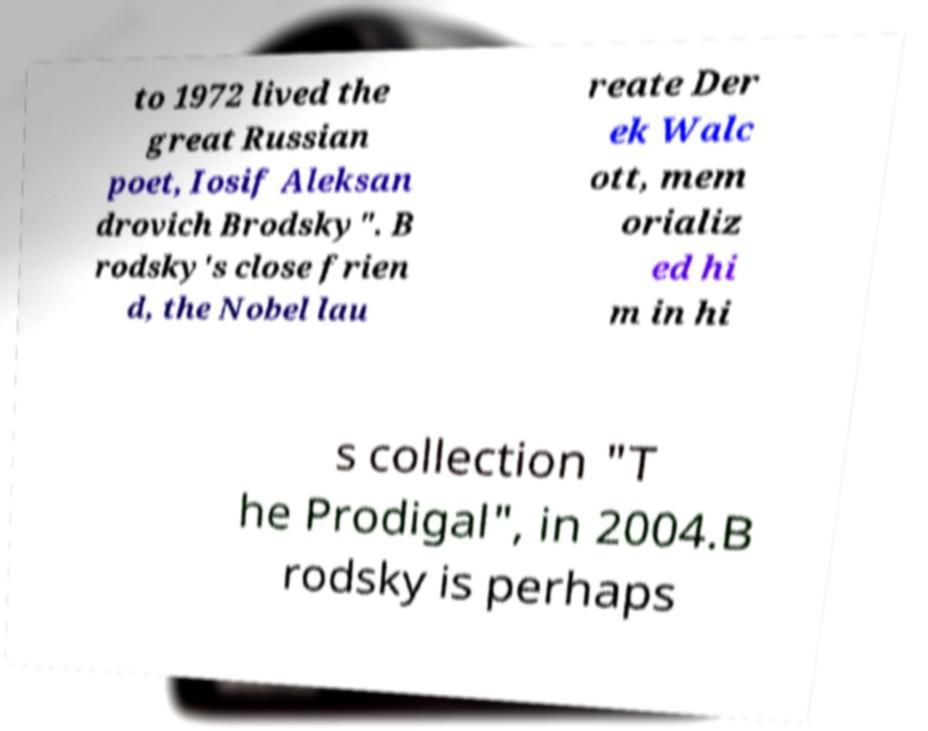Please identify and transcribe the text found in this image. to 1972 lived the great Russian poet, Iosif Aleksan drovich Brodsky". B rodsky's close frien d, the Nobel lau reate Der ek Walc ott, mem orializ ed hi m in hi s collection "T he Prodigal", in 2004.B rodsky is perhaps 